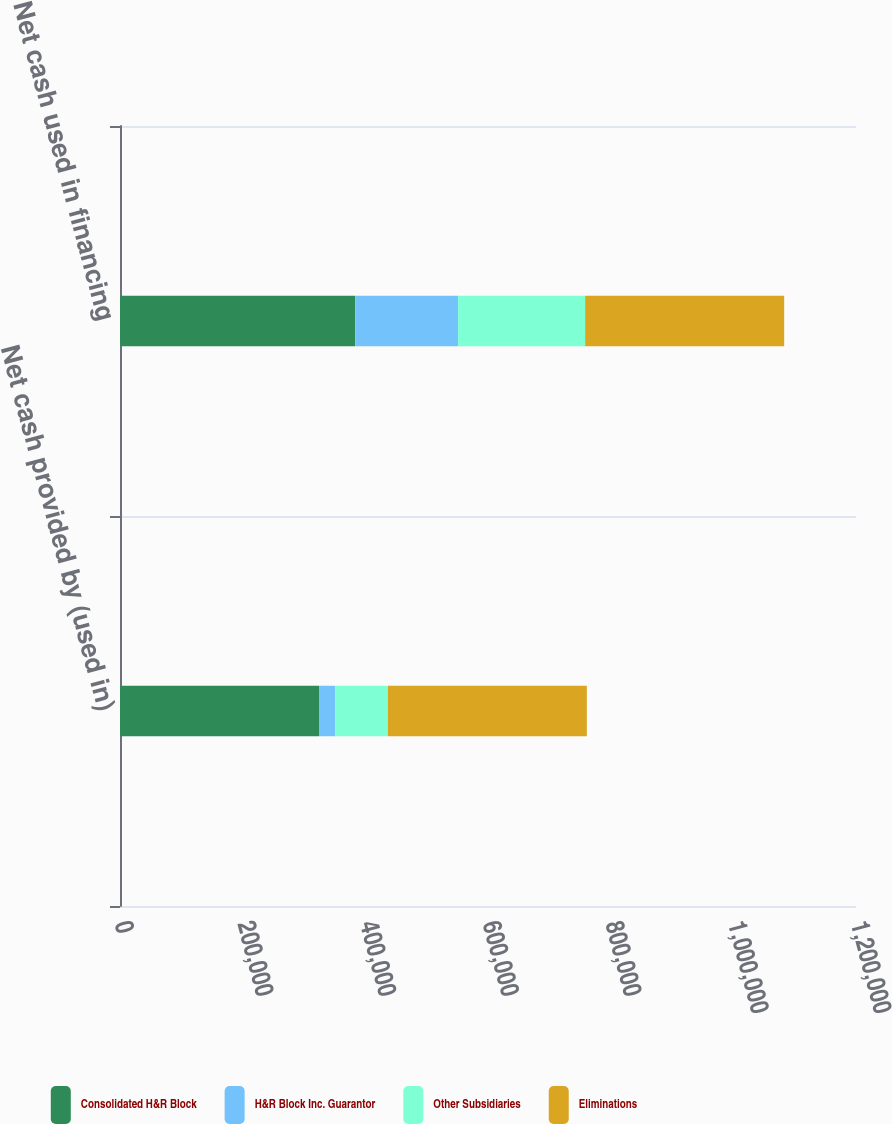<chart> <loc_0><loc_0><loc_500><loc_500><stacked_bar_chart><ecel><fcel>Net cash provided by (used in)<fcel>Net cash used in financing<nl><fcel>Consolidated H&R Block<fcel>324503<fcel>383430<nl><fcel>H&R Block Inc. Guarantor<fcel>26567<fcel>167738<nl><fcel>Other Subsidiaries<fcel>85600<fcel>207219<nl><fcel>Eliminations<fcel>324503<fcel>324503<nl></chart> 